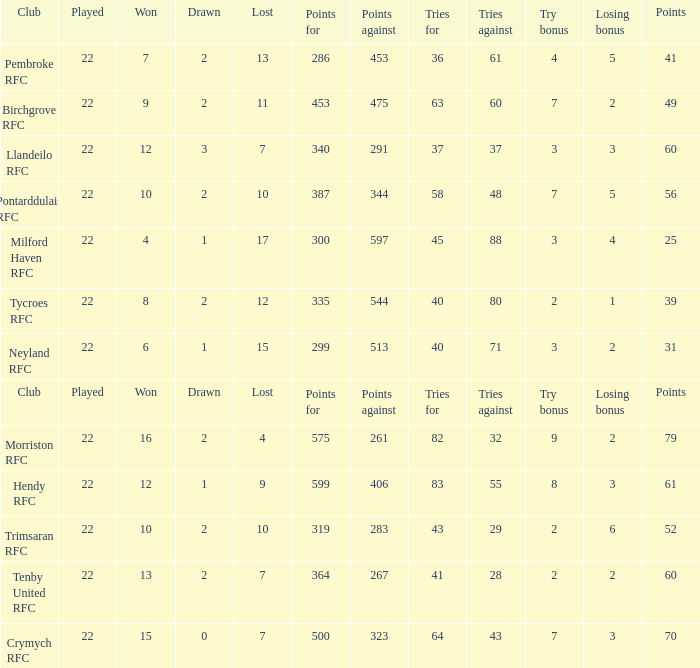 how many losing bonus with won being 10 and points against being 283 1.0. 